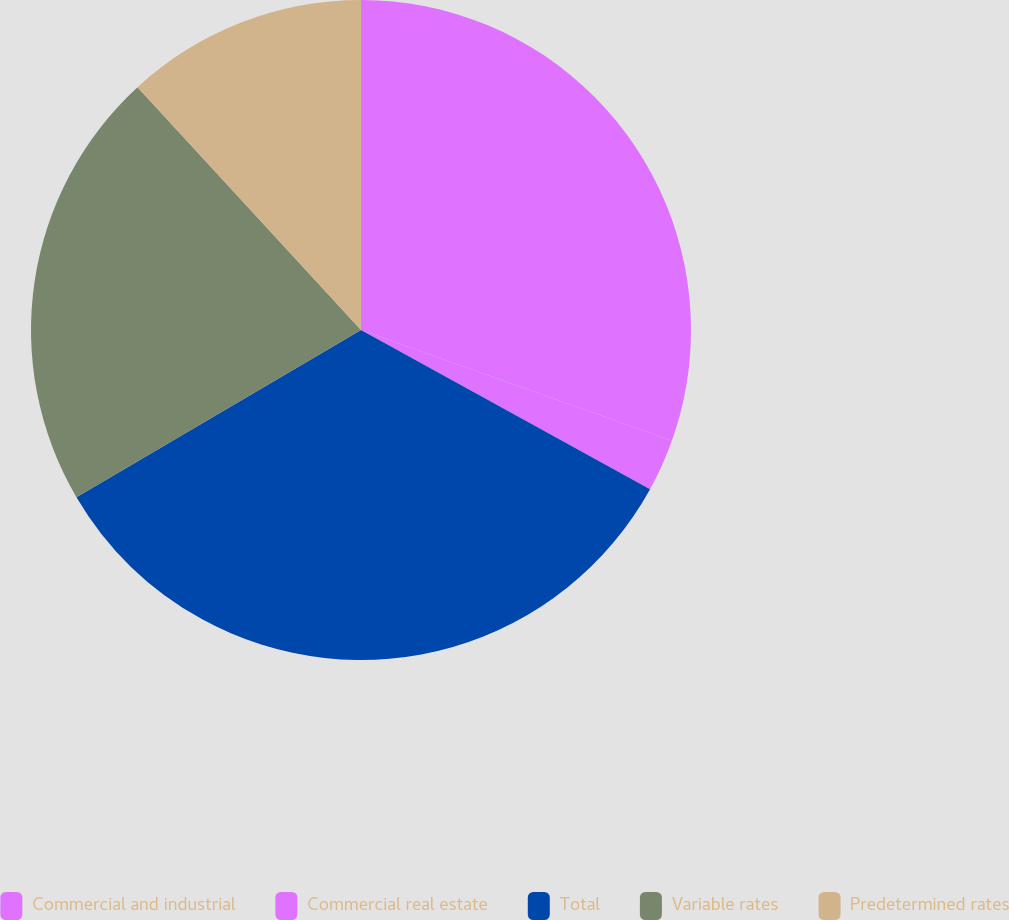Convert chart. <chart><loc_0><loc_0><loc_500><loc_500><pie_chart><fcel>Commercial and industrial<fcel>Commercial real estate<fcel>Total<fcel>Variable rates<fcel>Predetermined rates<nl><fcel>30.44%<fcel>2.57%<fcel>33.53%<fcel>21.61%<fcel>11.84%<nl></chart> 